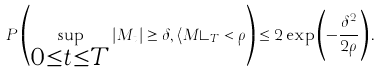Convert formula to latex. <formula><loc_0><loc_0><loc_500><loc_500>P \left ( \sup _ { \substack { 0 \leq t \leq T } } | M _ { t } | \geq \delta , \langle M \rangle _ { T } < \rho \right ) \leq 2 \exp \left ( - \frac { \delta ^ { 2 } } { 2 \rho } \right ) .</formula> 